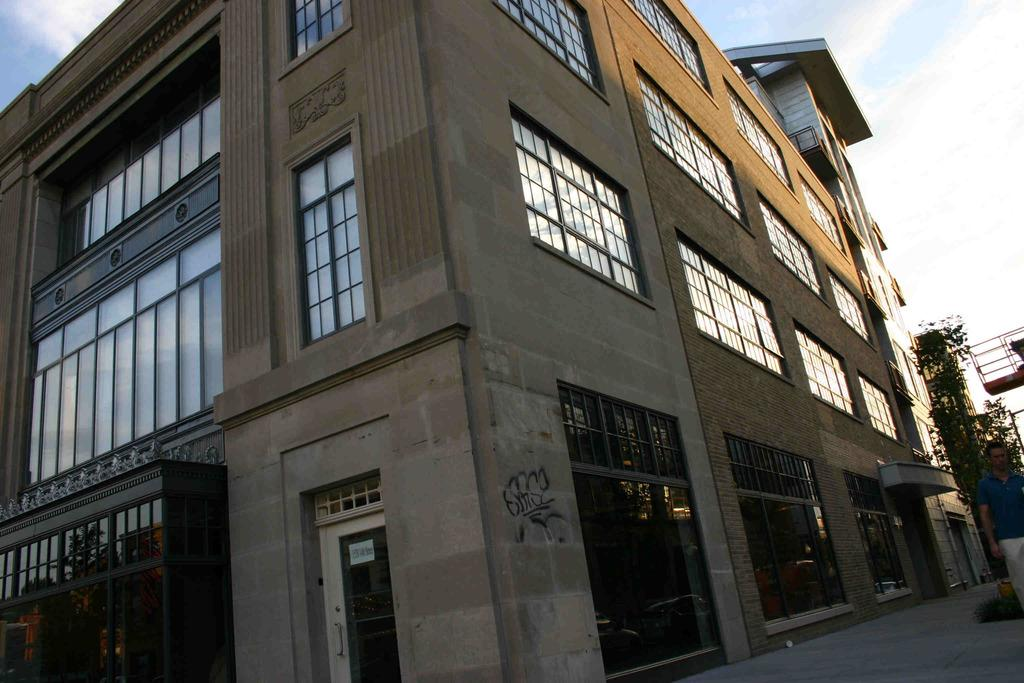What is the main structure in the foreground of the image? There is a building in the foreground of the image. Can you describe the person in the image? There is a person standing on the path to the right side of the image. What type of vegetation can be seen in the background of the image? There is a plant visible in the background of the image. What is visible in the sky in the background of the image? The sky is visible in the background of the image. What degree of dust can be seen on the glass in the image? There is no glass present in the image, so it is not possible to determine the degree of dust on it. 